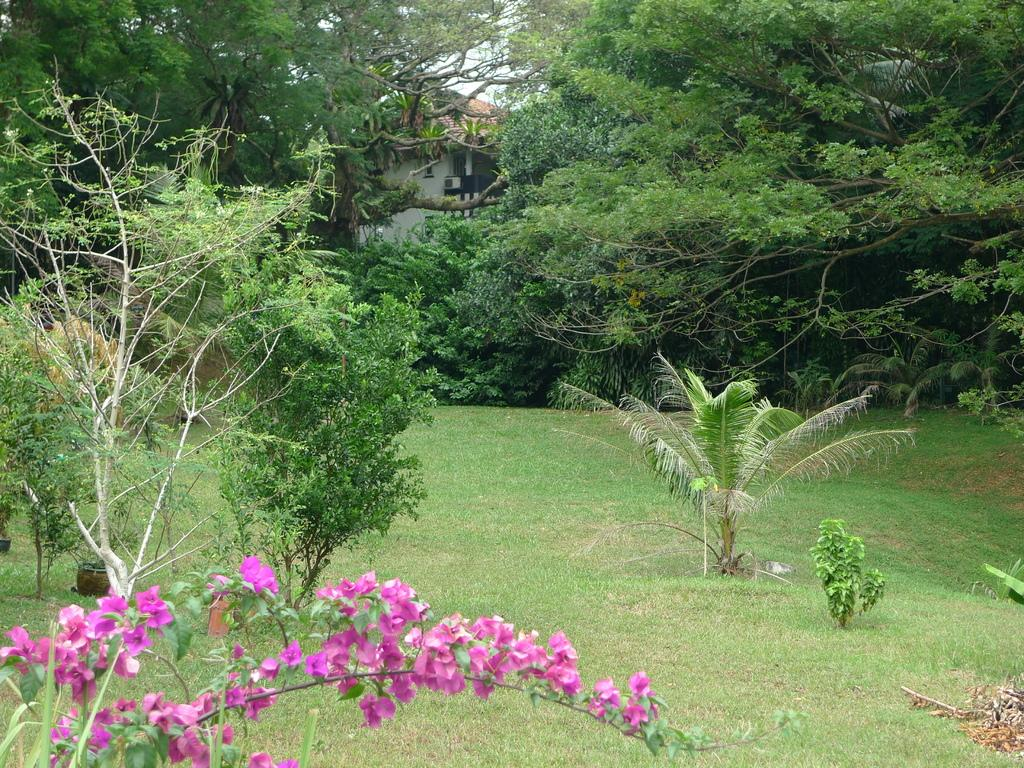What type of outdoor space is shown in the image? There is a garden in the image. What is the surface of the garden made of? The garden has a grass surface. What types of vegetation can be seen in the garden? There are plants in the garden. What can be seen in the background of the image? There are trees and a part of a house visible in the background. What committee is meeting in the garden in the image? There is no committee meeting in the garden in the image; it is a garden with plants and trees. 